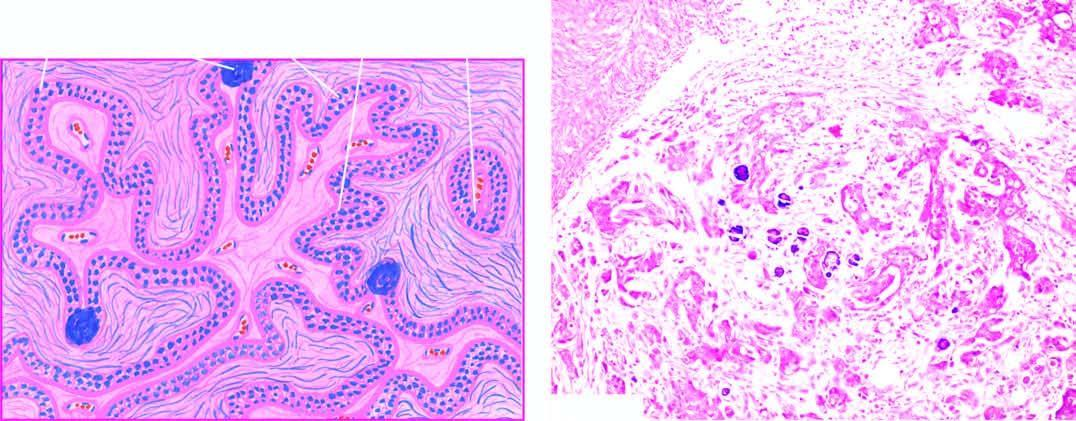what include stratification of low columnar epithelium lining the inner surface of the cyst and a few psammoma bodies?
Answer the question using a single word or phrase. Microscopic features 